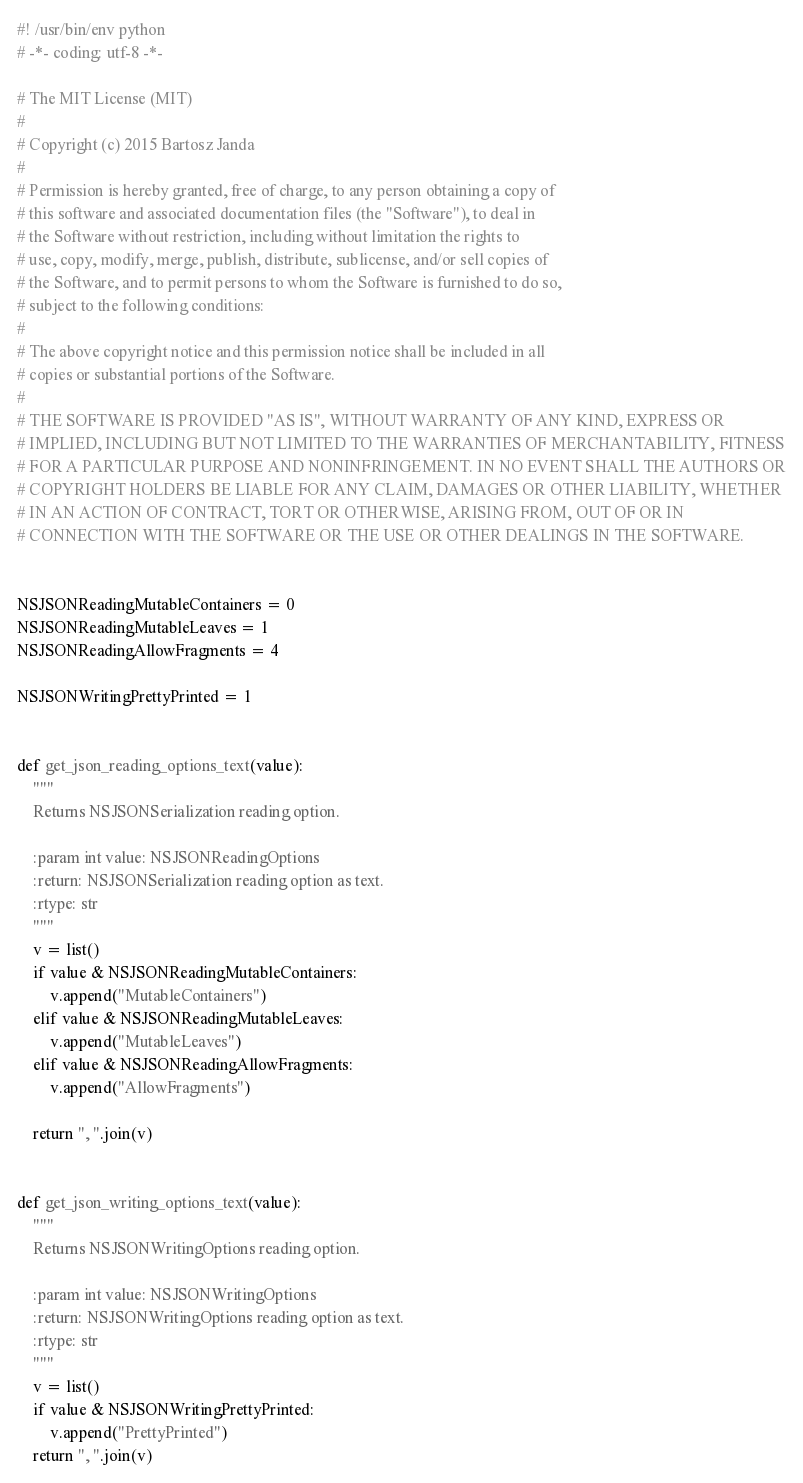Convert code to text. <code><loc_0><loc_0><loc_500><loc_500><_Python_>#! /usr/bin/env python
# -*- coding: utf-8 -*-

# The MIT License (MIT)
#
# Copyright (c) 2015 Bartosz Janda
#
# Permission is hereby granted, free of charge, to any person obtaining a copy of
# this software and associated documentation files (the "Software"), to deal in
# the Software without restriction, including without limitation the rights to
# use, copy, modify, merge, publish, distribute, sublicense, and/or sell copies of
# the Software, and to permit persons to whom the Software is furnished to do so,
# subject to the following conditions:
#
# The above copyright notice and this permission notice shall be included in all
# copies or substantial portions of the Software.
#
# THE SOFTWARE IS PROVIDED "AS IS", WITHOUT WARRANTY OF ANY KIND, EXPRESS OR
# IMPLIED, INCLUDING BUT NOT LIMITED TO THE WARRANTIES OF MERCHANTABILITY, FITNESS
# FOR A PARTICULAR PURPOSE AND NONINFRINGEMENT. IN NO EVENT SHALL THE AUTHORS OR
# COPYRIGHT HOLDERS BE LIABLE FOR ANY CLAIM, DAMAGES OR OTHER LIABILITY, WHETHER
# IN AN ACTION OF CONTRACT, TORT OR OTHERWISE, ARISING FROM, OUT OF OR IN
# CONNECTION WITH THE SOFTWARE OR THE USE OR OTHER DEALINGS IN THE SOFTWARE.


NSJSONReadingMutableContainers = 0
NSJSONReadingMutableLeaves = 1
NSJSONReadingAllowFragments = 4

NSJSONWritingPrettyPrinted = 1


def get_json_reading_options_text(value):
    """
    Returns NSJSONSerialization reading option.

    :param int value: NSJSONReadingOptions
    :return: NSJSONSerialization reading option as text.
    :rtype: str
    """
    v = list()
    if value & NSJSONReadingMutableContainers:
        v.append("MutableContainers")
    elif value & NSJSONReadingMutableLeaves:
        v.append("MutableLeaves")
    elif value & NSJSONReadingAllowFragments:
        v.append("AllowFragments")

    return ", ".join(v)


def get_json_writing_options_text(value):
    """
    Returns NSJSONWritingOptions reading option.

    :param int value: NSJSONWritingOptions
    :return: NSJSONWritingOptions reading option as text.
    :rtype: str
    """
    v = list()
    if value & NSJSONWritingPrettyPrinted:
        v.append("PrettyPrinted")
    return ", ".join(v)
</code> 